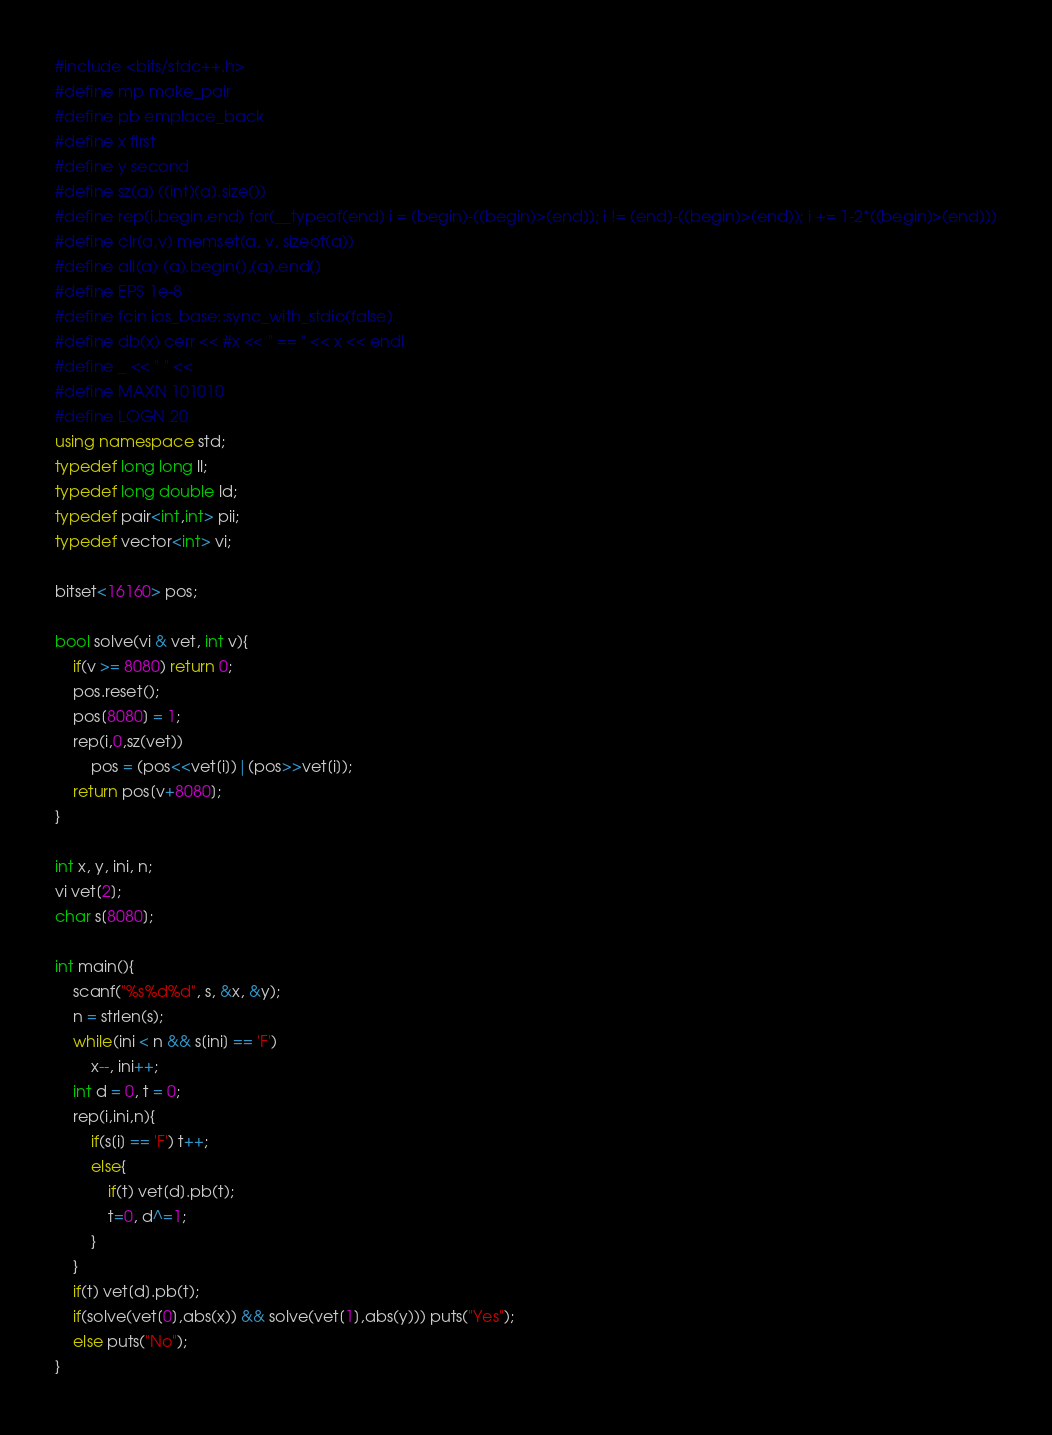<code> <loc_0><loc_0><loc_500><loc_500><_C++_>#include <bits/stdc++.h>
#define mp make_pair
#define pb emplace_back
#define x first
#define y second
#define sz(a) ((int)(a).size())
#define rep(i,begin,end) for(__typeof(end) i = (begin)-((begin)>(end)); i != (end)-((begin)>(end)); i += 1-2*((begin)>(end)))
#define clr(a,v) memset(a, v, sizeof(a))
#define all(a) (a).begin(),(a).end()
#define EPS 1e-8
#define fcin ios_base::sync_with_stdio(false)
#define db(x) cerr << #x << " == " << x << endl
#define _ << " " <<
#define MAXN 101010
#define LOGN 20
using namespace std;
typedef long long ll;
typedef long double ld;
typedef pair<int,int> pii;
typedef vector<int> vi;

bitset<16160> pos;

bool solve(vi & vet, int v){
	if(v >= 8080) return 0;
	pos.reset();
	pos[8080] = 1;
	rep(i,0,sz(vet))
		pos = (pos<<vet[i])|(pos>>vet[i]);
	return pos[v+8080];
}

int x, y, ini, n;
vi vet[2];
char s[8080];

int main(){
	scanf("%s%d%d", s, &x, &y);
	n = strlen(s);
	while(ini < n && s[ini] == 'F')
		x--, ini++;
	int d = 0, t = 0;
	rep(i,ini,n){
		if(s[i] == 'F') t++;
		else{
			if(t) vet[d].pb(t);
			t=0, d^=1;
		}
	}
	if(t) vet[d].pb(t);
	if(solve(vet[0],abs(x)) && solve(vet[1],abs(y))) puts("Yes");
	else puts("No");
}

</code> 